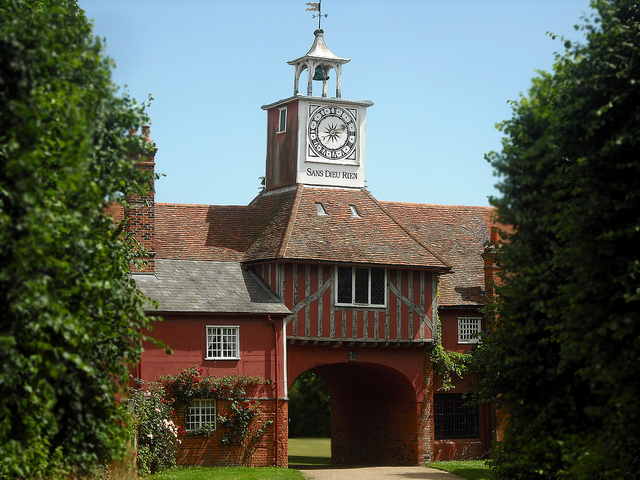<image>What tree is on the left? I don't know what tree is on the left. It could be an oak, pine, bush, shrub, evergreen or a green tree. Does the building in the back have an elevator? It's uncertain if the building in the back has an elevator. What tree is on the left? I don't know what tree is on the left. It can be an oak, pine, bush, shrub, or evergreen tree. Does the building in the back have an elevator? I am not sure if the building in the back has an elevator. It is possible that it doesn't have an elevator. 